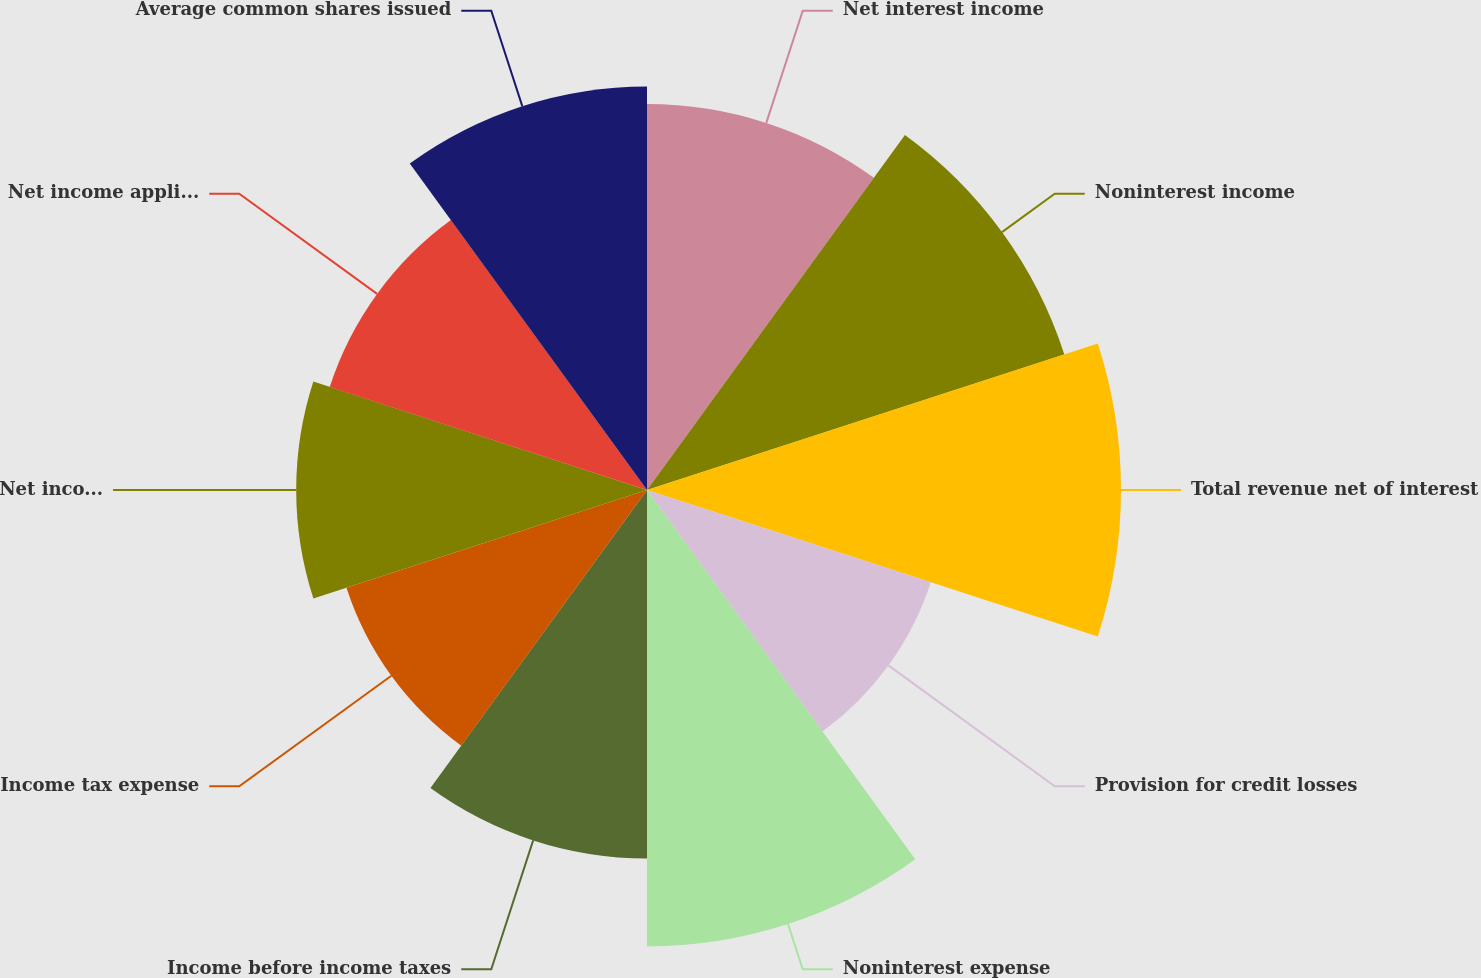Convert chart to OTSL. <chart><loc_0><loc_0><loc_500><loc_500><pie_chart><fcel>Net interest income<fcel>Noninterest income<fcel>Total revenue net of interest<fcel>Provision for credit losses<fcel>Noninterest expense<fcel>Income before income taxes<fcel>Income tax expense<fcel>Net income<fcel>Net income applicable to<fcel>Average common shares issued<nl><fcel>10.09%<fcel>11.47%<fcel>12.39%<fcel>7.8%<fcel>11.93%<fcel>9.63%<fcel>8.26%<fcel>9.17%<fcel>8.72%<fcel>10.55%<nl></chart> 